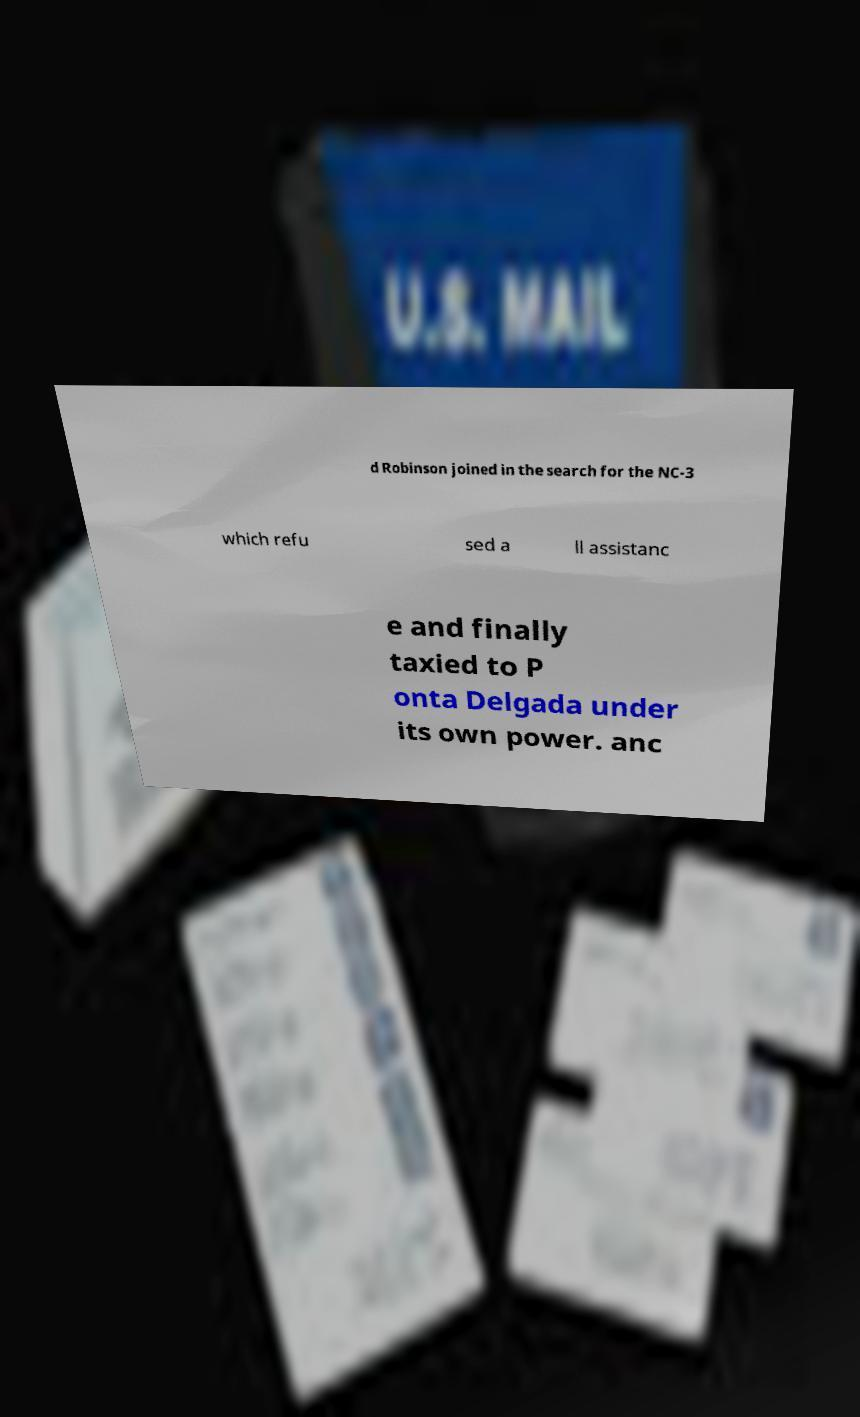Can you accurately transcribe the text from the provided image for me? d Robinson joined in the search for the NC-3 which refu sed a ll assistanc e and finally taxied to P onta Delgada under its own power. anc 